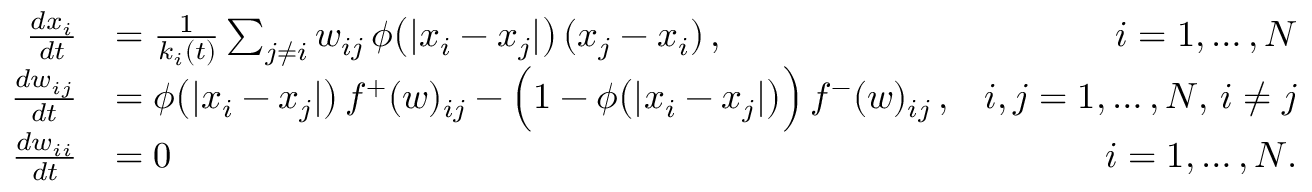<formula> <loc_0><loc_0><loc_500><loc_500>\begin{array} { r l r } { \frac { d x _ { i } } { d t } } & { = \frac { 1 } { k _ { i } ( t ) } \sum _ { j \neq i } w _ { i j } \, \phi \left ( | x _ { i } - x _ { j } | \right ) \, ( x _ { j } - x _ { i } ) \, , } & { i = 1 , \dots , N } \\ { \frac { d w _ { i j } } { d t } } & { = \phi \left ( | x _ { i } - x _ { j } | \right ) \, f ^ { + } ( w ) _ { i j } - \left ( 1 - \phi \left ( | x _ { i } - x _ { j } | \right ) \right ) \, f ^ { - } ( w ) _ { i j } \, , } & { i , j = 1 , \dots , N , \, i \neq j } \\ { \frac { d w _ { i i } } { d t } } & { = 0 } & { i = 1 , \dots , N . } \end{array}</formula> 